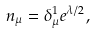<formula> <loc_0><loc_0><loc_500><loc_500>n _ { \mu } = \delta _ { \mu } ^ { 1 } e ^ { \lambda / 2 } ,</formula> 